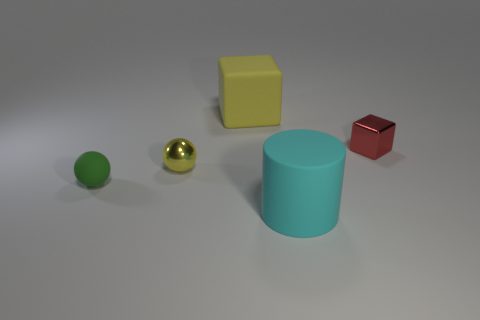Is there a rubber ball?
Offer a terse response. Yes. There is a rubber thing behind the small red object that is in front of the large matte object behind the cylinder; how big is it?
Offer a terse response. Large. There is a cyan thing that is the same size as the yellow matte cube; what is its shape?
Provide a succinct answer. Cylinder. Is there anything else that is made of the same material as the small green sphere?
Your answer should be compact. Yes. How many things are small metal objects that are on the right side of the cyan thing or rubber objects?
Give a very brief answer. 4. There is a large matte thing that is to the right of the large cube that is to the left of the small cube; is there a green matte object that is to the right of it?
Ensure brevity in your answer.  No. How many red things are there?
Provide a short and direct response. 1. How many things are tiny balls that are in front of the yellow metallic ball or small things behind the tiny rubber sphere?
Offer a very short reply. 3. Do the sphere to the right of the green rubber object and the cyan cylinder have the same size?
Ensure brevity in your answer.  No. What size is the other yellow object that is the same shape as the small rubber thing?
Provide a succinct answer. Small. 